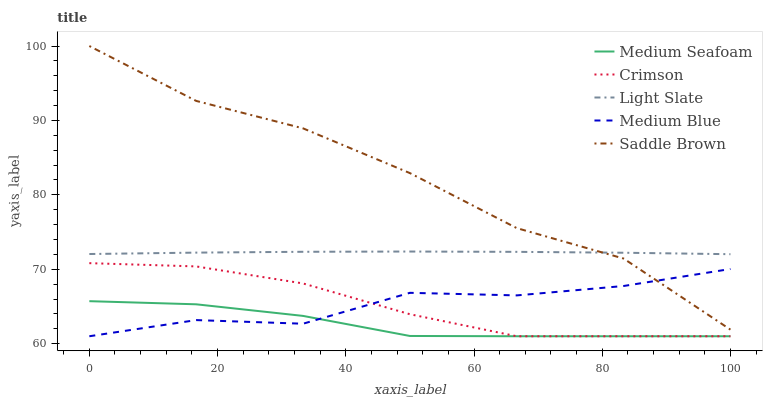Does Medium Seafoam have the minimum area under the curve?
Answer yes or no. Yes. Does Saddle Brown have the maximum area under the curve?
Answer yes or no. Yes. Does Light Slate have the minimum area under the curve?
Answer yes or no. No. Does Light Slate have the maximum area under the curve?
Answer yes or no. No. Is Light Slate the smoothest?
Answer yes or no. Yes. Is Saddle Brown the roughest?
Answer yes or no. Yes. Is Medium Blue the smoothest?
Answer yes or no. No. Is Medium Blue the roughest?
Answer yes or no. No. Does Light Slate have the lowest value?
Answer yes or no. No. Does Saddle Brown have the highest value?
Answer yes or no. Yes. Does Light Slate have the highest value?
Answer yes or no. No. Is Crimson less than Light Slate?
Answer yes or no. Yes. Is Light Slate greater than Crimson?
Answer yes or no. Yes. Does Medium Blue intersect Medium Seafoam?
Answer yes or no. Yes. Is Medium Blue less than Medium Seafoam?
Answer yes or no. No. Is Medium Blue greater than Medium Seafoam?
Answer yes or no. No. Does Crimson intersect Light Slate?
Answer yes or no. No. 